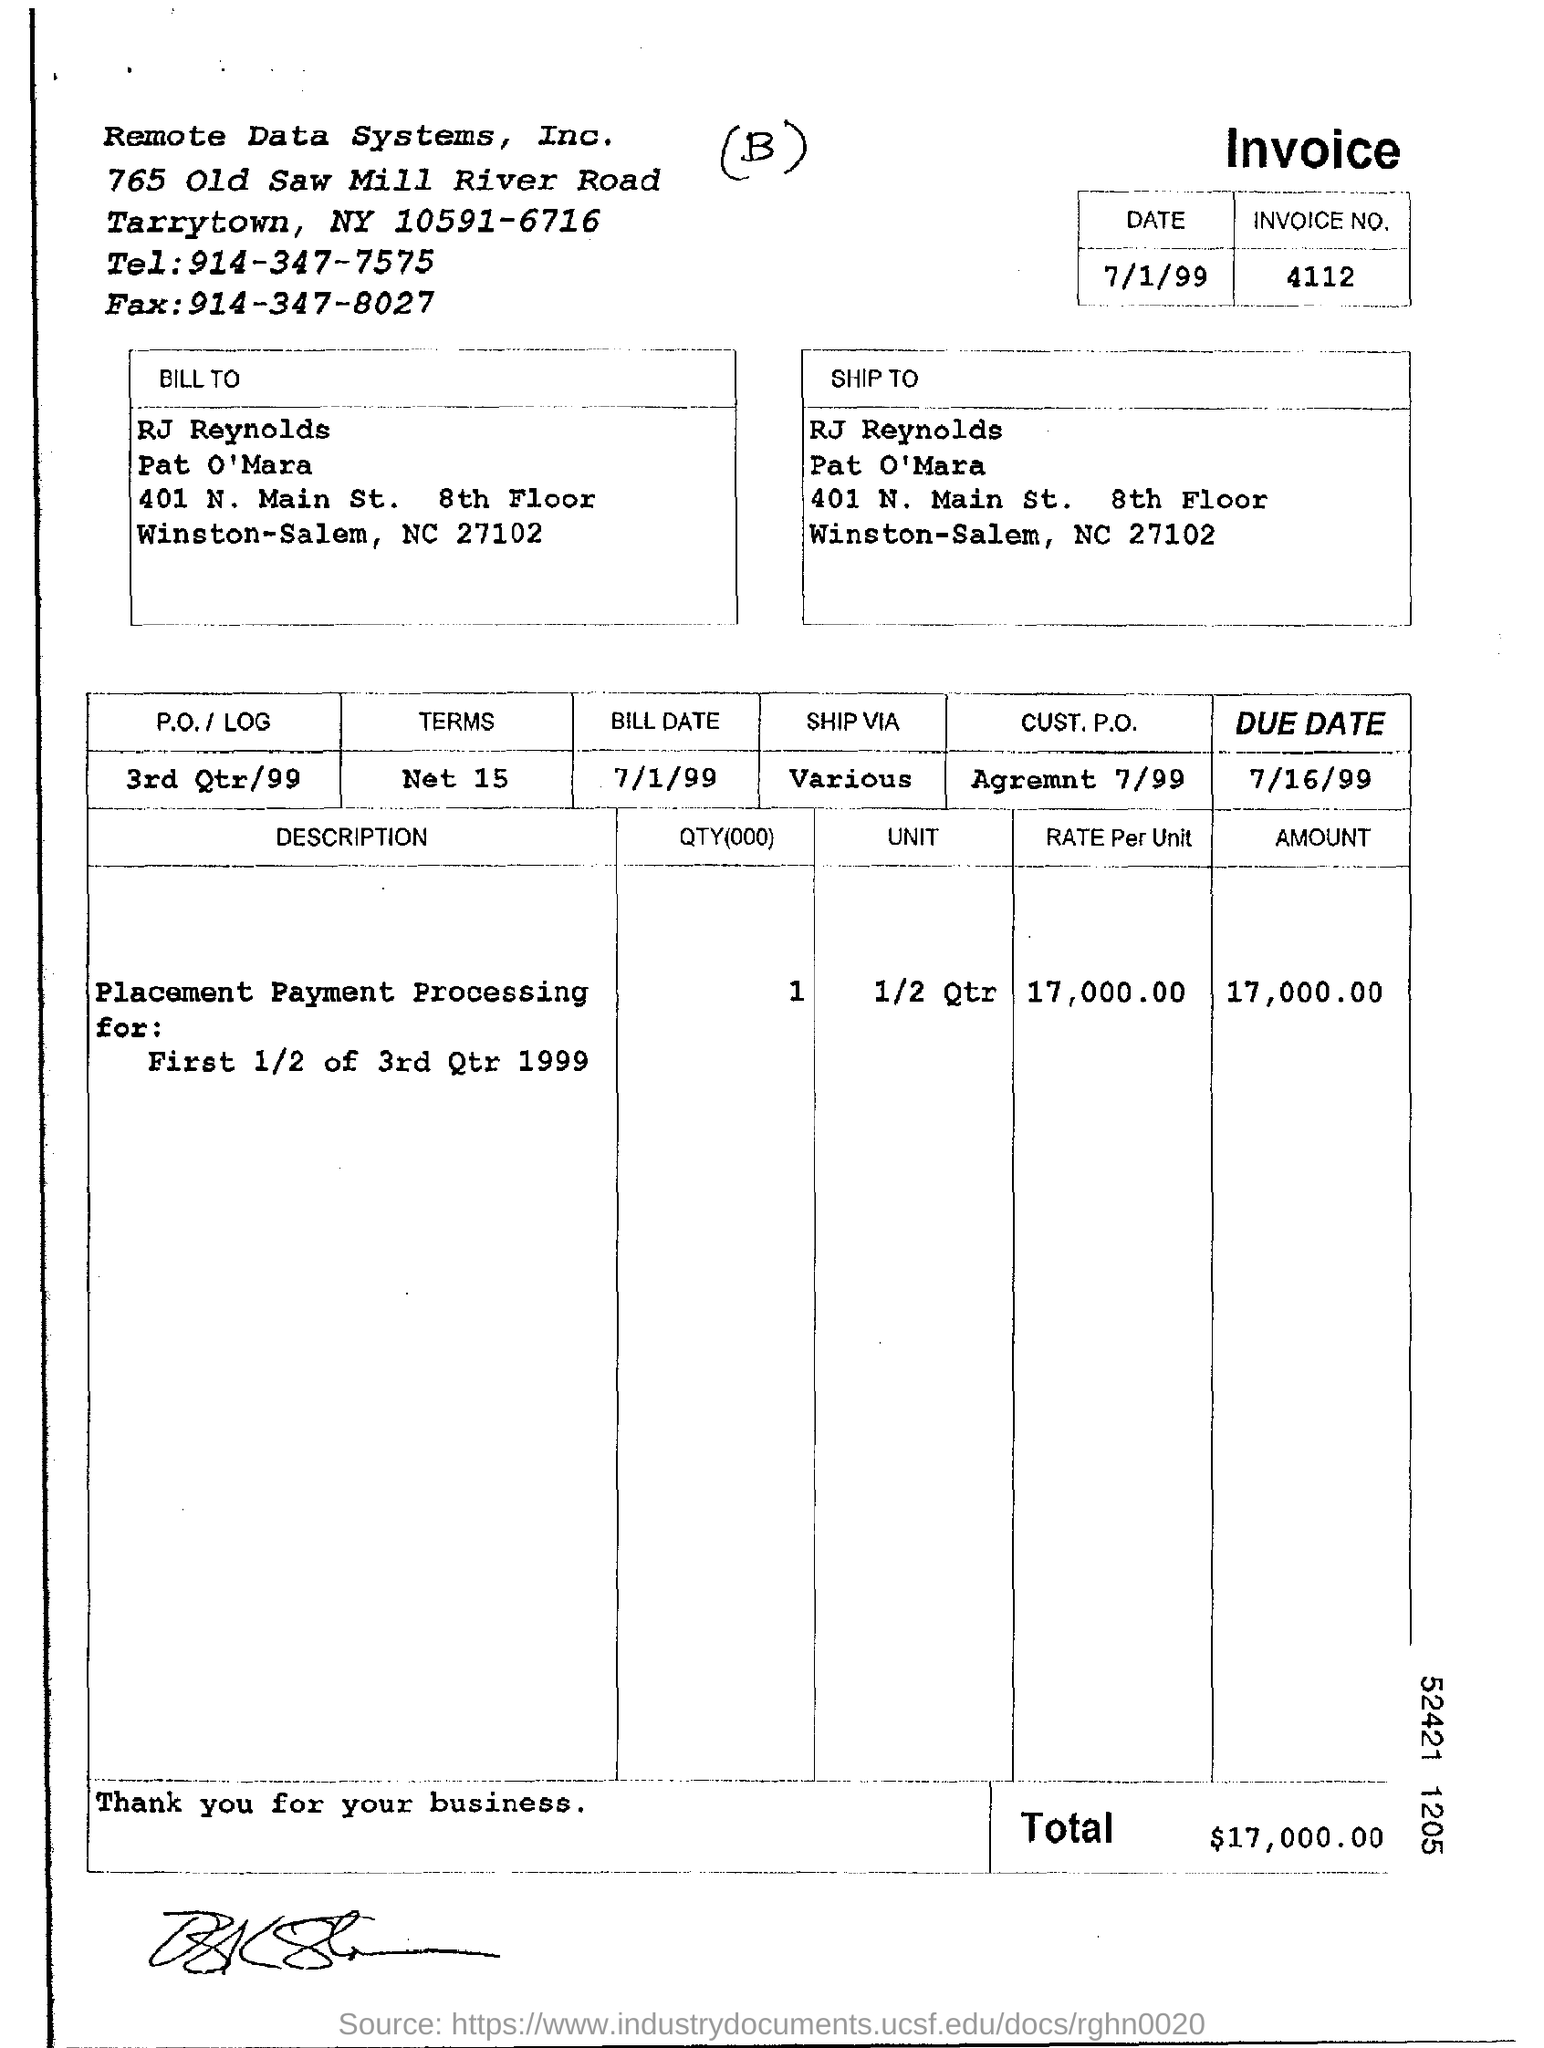What is invoice number?
Give a very brief answer. 4112. What is the total amount mentioned in the invoice?
Give a very brief answer. 17,000.00. What is bill date?
Provide a short and direct response. 7/1/99. What is due date?
Your answer should be compact. 7/16/99. 